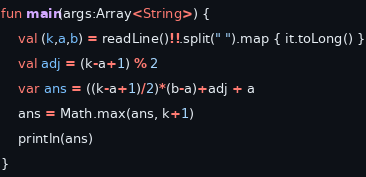Convert code to text. <code><loc_0><loc_0><loc_500><loc_500><_Kotlin_>fun main(args:Array<String>) {
    val (k,a,b) = readLine()!!.split(" ").map { it.toLong() }
    val adj = (k-a+1) % 2
    var ans = ((k-a+1)/2)*(b-a)+adj + a
    ans = Math.max(ans, k+1)
    println(ans)
}
</code> 